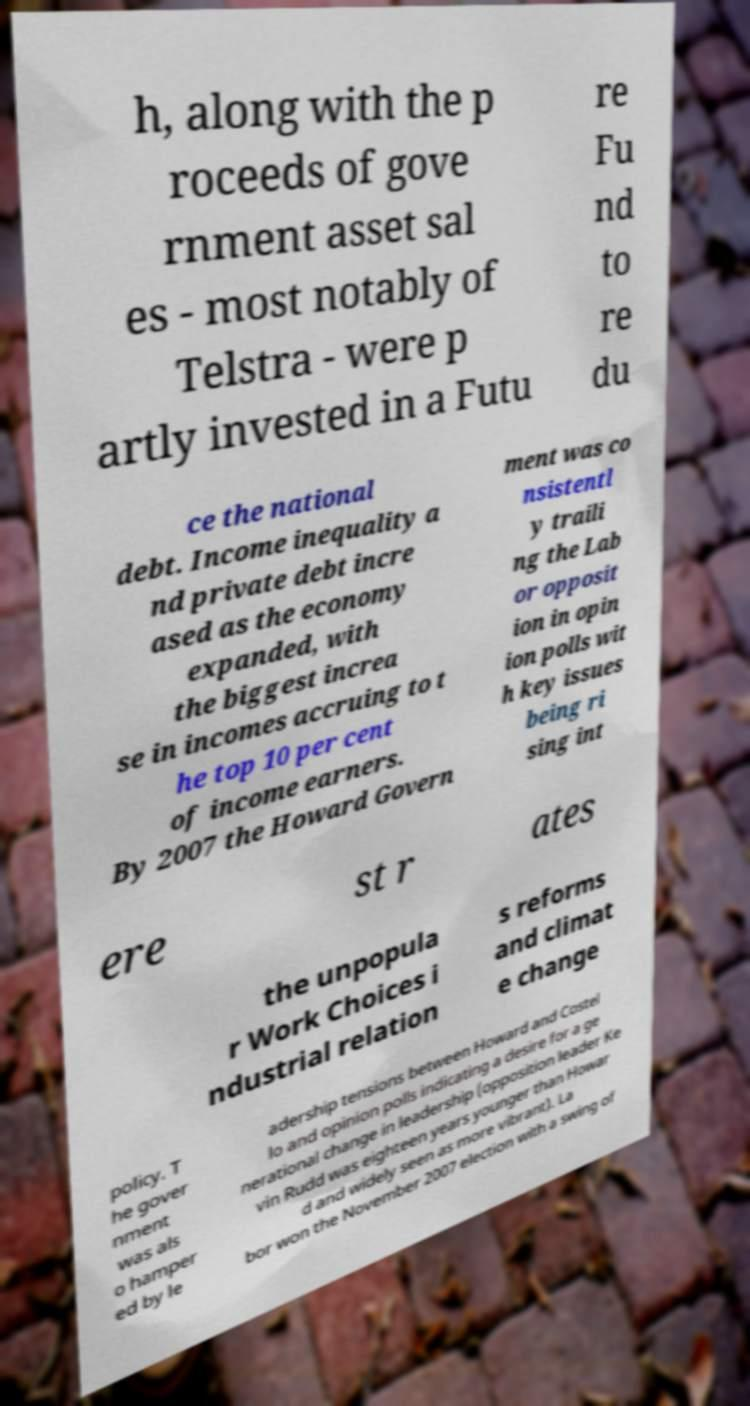Could you assist in decoding the text presented in this image and type it out clearly? h, along with the p roceeds of gove rnment asset sal es - most notably of Telstra - were p artly invested in a Futu re Fu nd to re du ce the national debt. Income inequality a nd private debt incre ased as the economy expanded, with the biggest increa se in incomes accruing to t he top 10 per cent of income earners. By 2007 the Howard Govern ment was co nsistentl y traili ng the Lab or opposit ion in opin ion polls wit h key issues being ri sing int ere st r ates the unpopula r Work Choices i ndustrial relation s reforms and climat e change policy. T he gover nment was als o hamper ed by le adership tensions between Howard and Costel lo and opinion polls indicating a desire for a ge nerational change in leadership (opposition leader Ke vin Rudd was eighteen years younger than Howar d and widely seen as more vibrant). La bor won the November 2007 election with a swing of 